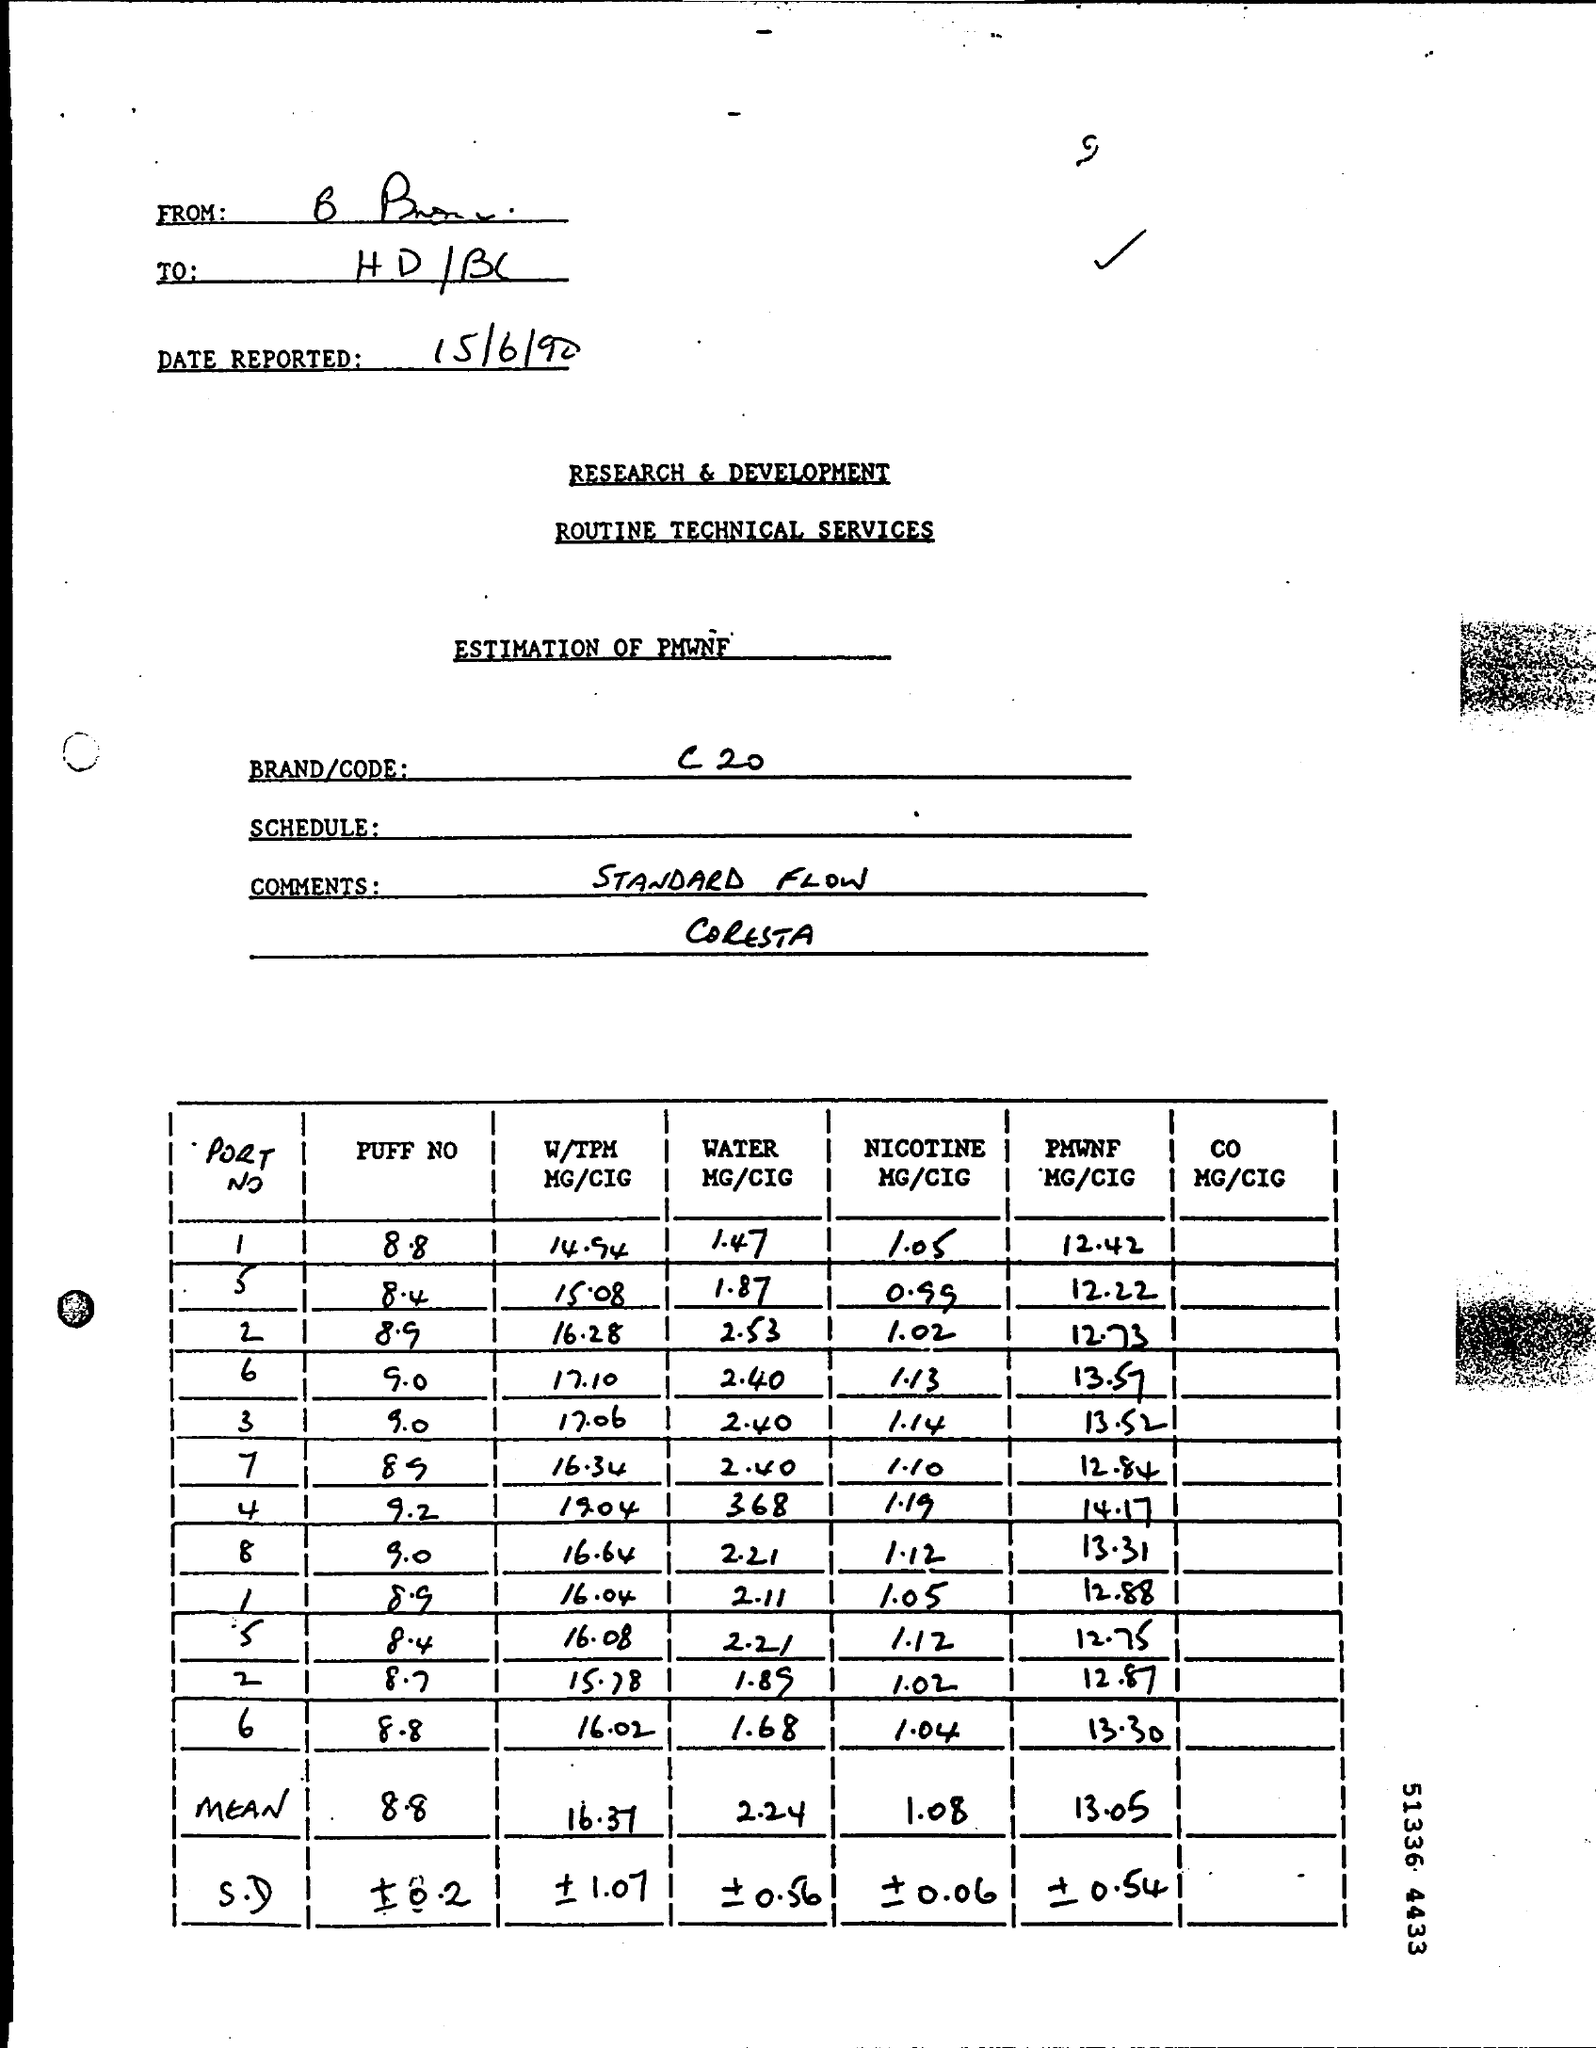What is written in the BRAND/CODE Field ?
Provide a succinct answer. C20. 